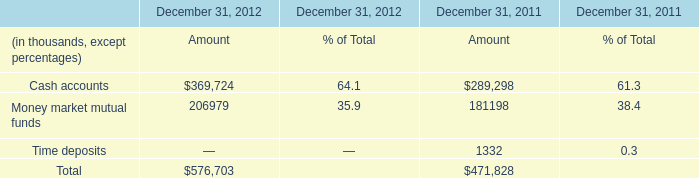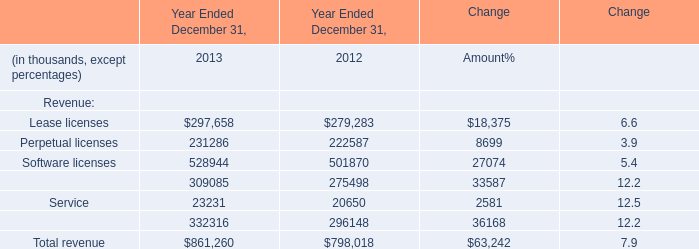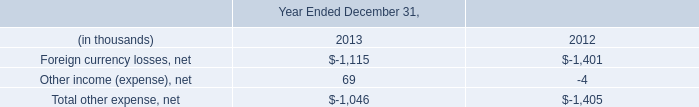What's the average of Lease licenses of Year Ended December 31, 2013, and Cash accounts of December 31, 2012 Amount ? 
Computations: ((297658.0 + 369724.0) / 2)
Answer: 333691.0. 